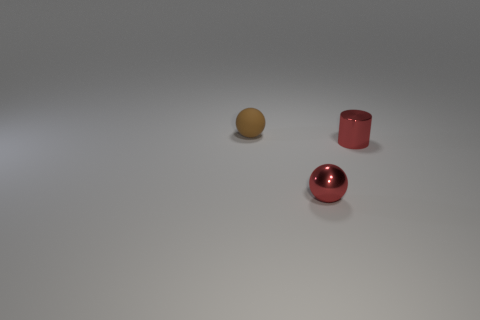Add 1 cylinders. How many objects exist? 4 Subtract all cylinders. How many objects are left? 2 Subtract 0 gray cylinders. How many objects are left? 3 Subtract all small brown cylinders. Subtract all red metallic things. How many objects are left? 1 Add 2 cylinders. How many cylinders are left? 3 Add 3 tiny metal things. How many tiny metal things exist? 5 